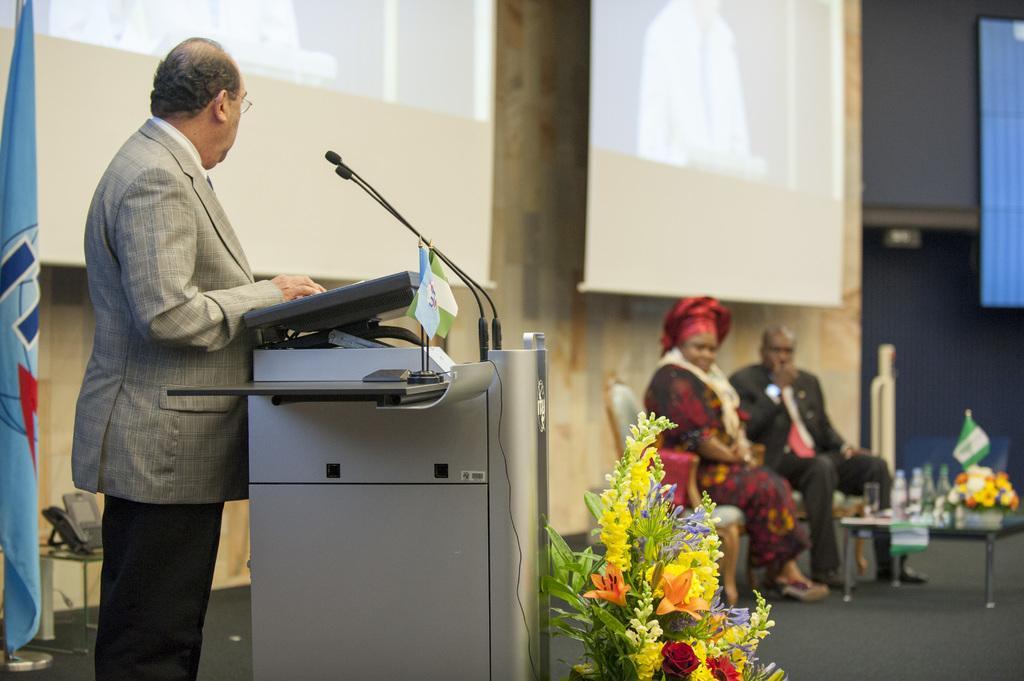Please provide a concise description of this image. In this image there is a man standing near the podium. Behind him there is a flag. On the left side there are two other persons who are sitting in the chair on the stage. At the bottom there is a flower vase beside the podium. At the top there are two screens. There is a table on which there are glasses, flower vase and a flag on the right side. 